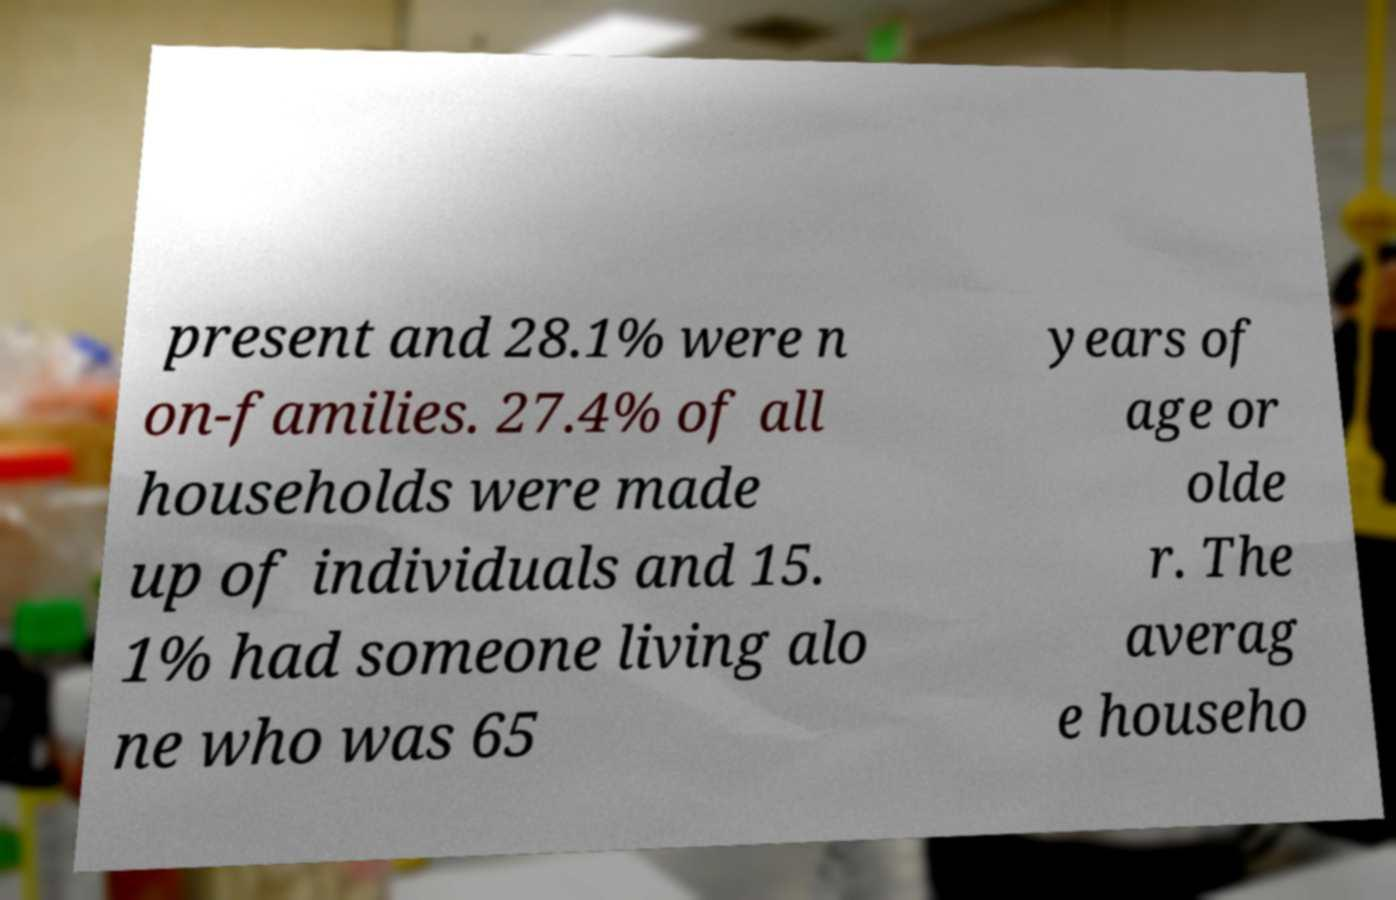Please read and relay the text visible in this image. What does it say? present and 28.1% were n on-families. 27.4% of all households were made up of individuals and 15. 1% had someone living alo ne who was 65 years of age or olde r. The averag e househo 